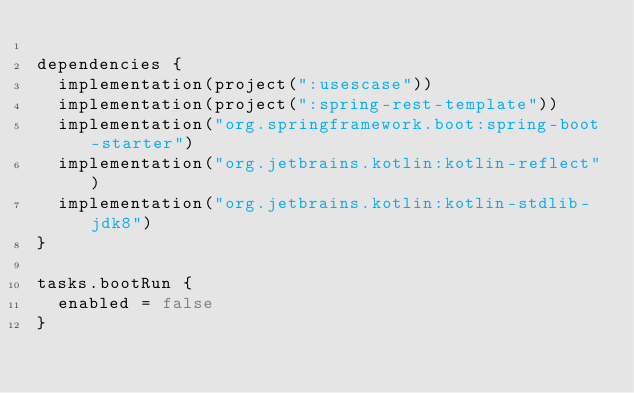Convert code to text. <code><loc_0><loc_0><loc_500><loc_500><_Kotlin_>
dependencies {
	implementation(project(":usescase"))
	implementation(project(":spring-rest-template"))
	implementation("org.springframework.boot:spring-boot-starter")
	implementation("org.jetbrains.kotlin:kotlin-reflect")
	implementation("org.jetbrains.kotlin:kotlin-stdlib-jdk8")
}

tasks.bootRun {
	enabled = false
}</code> 